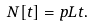<formula> <loc_0><loc_0><loc_500><loc_500>N [ t ] = p L t .</formula> 